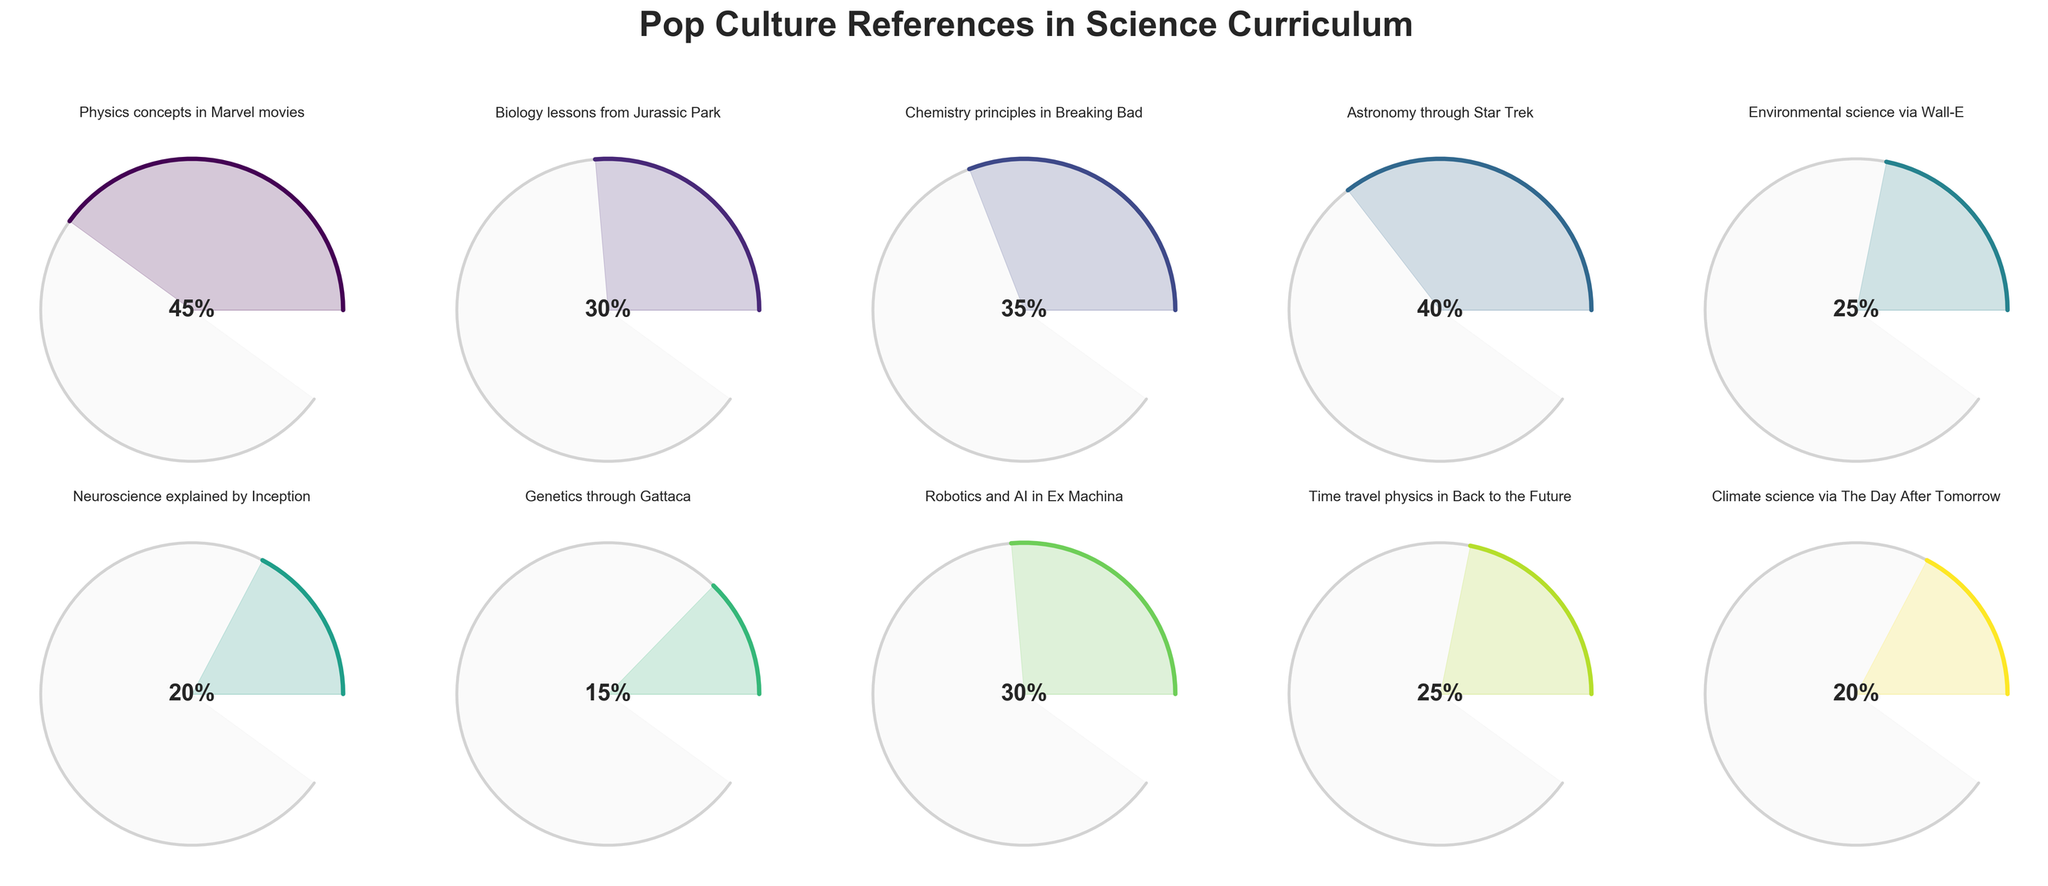What is the title of the figure? The title of the figure is clearly written at the top and is larger than other text elements, making it easy to identify.
Answer: "Pop Culture References in Science Curriculum" Which pop culture reference topic has the highest percentage of curriculum coverage? By observing the content and the percentage displayed inside the gauges, it is possible to determine which has the highest value.
Answer: Physics concepts in Marvel movies Which topic has the lowest coverage percentage? By scanning through all the percentage values, we need to identify the smallest one.
Answer: Genetics through Gattaca What is the total coverage percentage of all the topics combined? Add all the percentages together: 45, 30, 35, 40, 25, 20, 15, 30, 25, and 20. Total = 285
Answer: 285% Compare the coverage between "Neuroscience explained by Inception" and "Chemistry principles in Breaking Bad." Which is higher and by how much? Subtract the percentage of the lower coverage from the higher one: 35 (Breaking Bad) - 20 (Inception) = 15
Answer: Breaking Bad by 15% What is the average percentage of curriculum coverage for all the topics? Sum all the percentages (285) and divide by the number of topics (10). Average = 285 / 10 = 28.5%
Answer: 28.5% What are the two topics with exactly the same percentage coverage? Scan through the data to identify matching percentages. Both are 30%.
Answer: Biology lessons from Jurassic Park and Robotics and AI in Ex Machina Which pop culture reference topics have a coverage percentage greater than 25%? Identify all topics with values higher than 25%. They are 45%, 30%, 35%, and 40%.
Answer: Physics concepts in Marvel movies, Biology lessons from Jurassic Park, Chemistry principles in Breaking Bad, Astronomy through Star Trek, Robotics and AI in Ex Machina What is the combined percentage coverage of "Time travel physics in Back to the Future" and "Climate science via The Day After Tomorrow"? Add the percentages together: 25 (Back to the Future) + 20 (Day After Tomorrow) = 45
Answer: 45% What is the percentage difference between "Astronomy through Star Trek" and "Environmental science via Wall-E"? Subtract the smaller percentage from the larger one: 40 (Star Trek) - 25 (Wall-E) = 15
Answer: 15% 